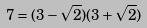Convert formula to latex. <formula><loc_0><loc_0><loc_500><loc_500>7 = ( 3 - \sqrt { 2 } ) ( 3 + \sqrt { 2 } )</formula> 